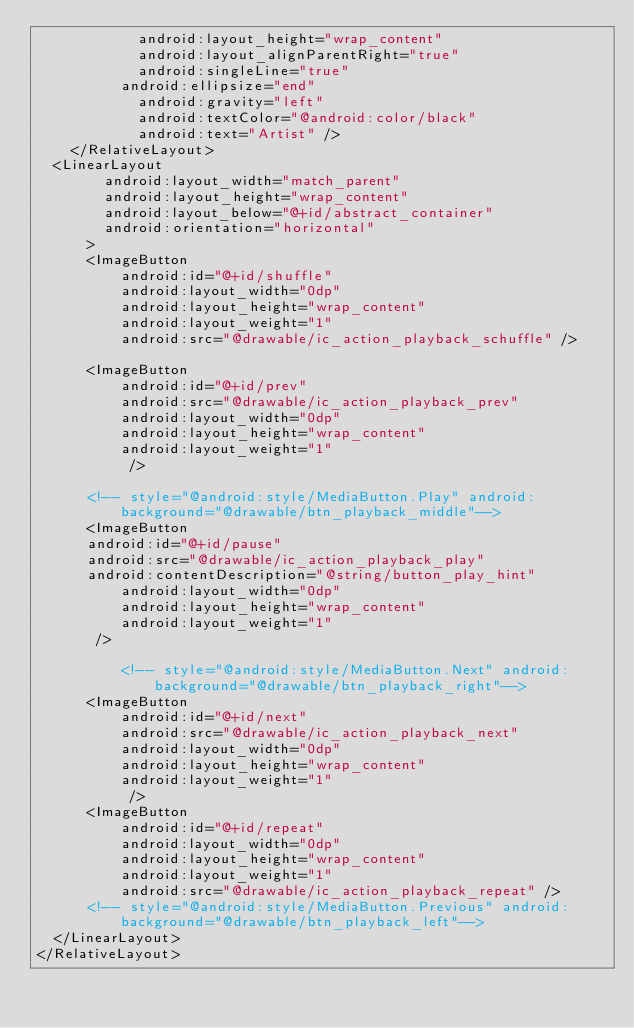Convert code to text. <code><loc_0><loc_0><loc_500><loc_500><_XML_>	          android:layout_height="wrap_content"
	          android:layout_alignParentRight="true"
	          android:singleLine="true"
   			  android:ellipsize="end"
	          android:gravity="left"
	          android:textColor="@android:color/black"
	          android:text="Artist" />
    </RelativeLayout>
	<LinearLayout 
        android:layout_width="match_parent"
        android:layout_height="wrap_content"
        android:layout_below="@+id/abstract_container"
        android:orientation="horizontal"
	    > 
	    <ImageButton
	        android:id="@+id/shuffle"
	        android:layout_width="0dp"
	        android:layout_height="wrap_content"
	        android:layout_weight="1"
	        android:src="@drawable/ic_action_playback_schuffle" />
	
	   	<ImageButton
	        android:id="@+id/prev"
	        android:src="@drawable/ic_action_playback_prev"
	        android:layout_width="0dp"
	        android:layout_height="wrap_content"
	        android:layout_weight="1"
	         />  
	
			<!-- style="@android:style/MediaButton.Play" android:background="@drawable/btn_playback_middle"-->
	    <ImageButton
			android:id="@+id/pause"
			android:src="@drawable/ic_action_playback_play"
			android:contentDescription="@string/button_play_hint"
	        android:layout_width="0dp"
	        android:layout_height="wrap_content"
	        android:layout_weight="1"
			 />
	        
	        <!-- style="@android:style/MediaButton.Next" android:background="@drawable/btn_playback_right"-->
	    <ImageButton
	        android:id="@+id/next"
	        android:src="@drawable/ic_action_playback_next"
	        android:layout_width="0dp"
	        android:layout_height="wrap_content"
	        android:layout_weight="1"
	         />
	    <ImageButton
	        android:id="@+id/repeat"
	        android:layout_width="0dp"
	        android:layout_height="wrap_content"
	        android:layout_weight="1"
	        android:src="@drawable/ic_action_playback_repeat" />
			<!-- style="@android:style/MediaButton.Previous" android:background="@drawable/btn_playback_left"-->
	</LinearLayout>       
</RelativeLayout></code> 